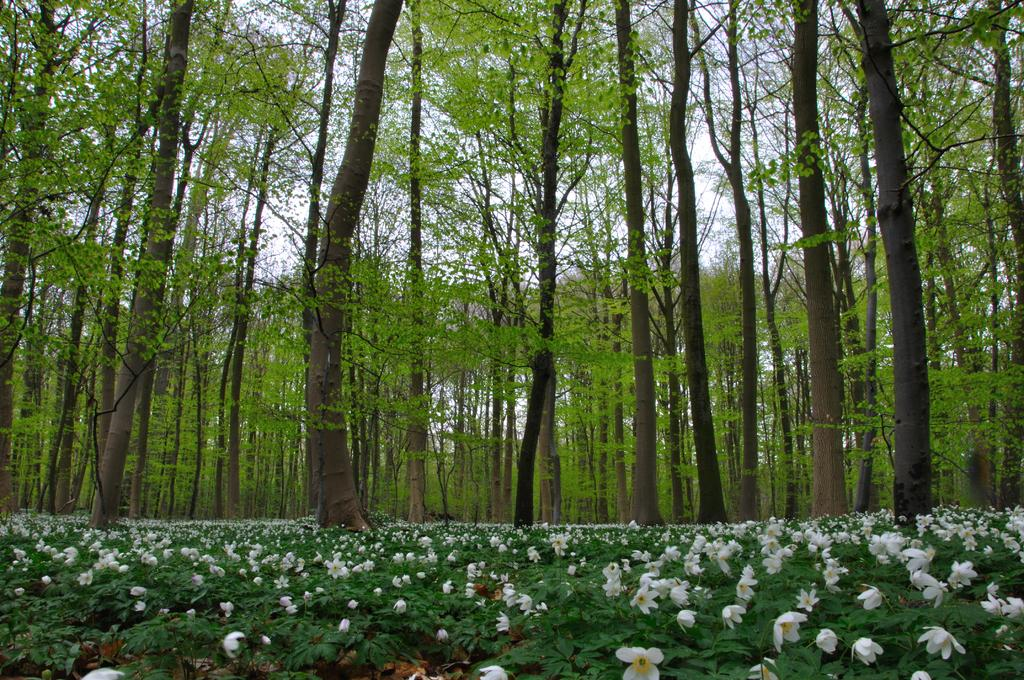What type of vegetation can be seen in the image? There are trees in the image. What is visible at the top of the image? The sky is visible at the top of the image. What color are the flowers on the plants at the bottom of the image? The flowers on the plants at the bottom of the image are white. Where is the meeting taking place in the image? There is no meeting present in the image. What type of badge can be seen on the trees in the image? There are no badges present on the trees in the image. 